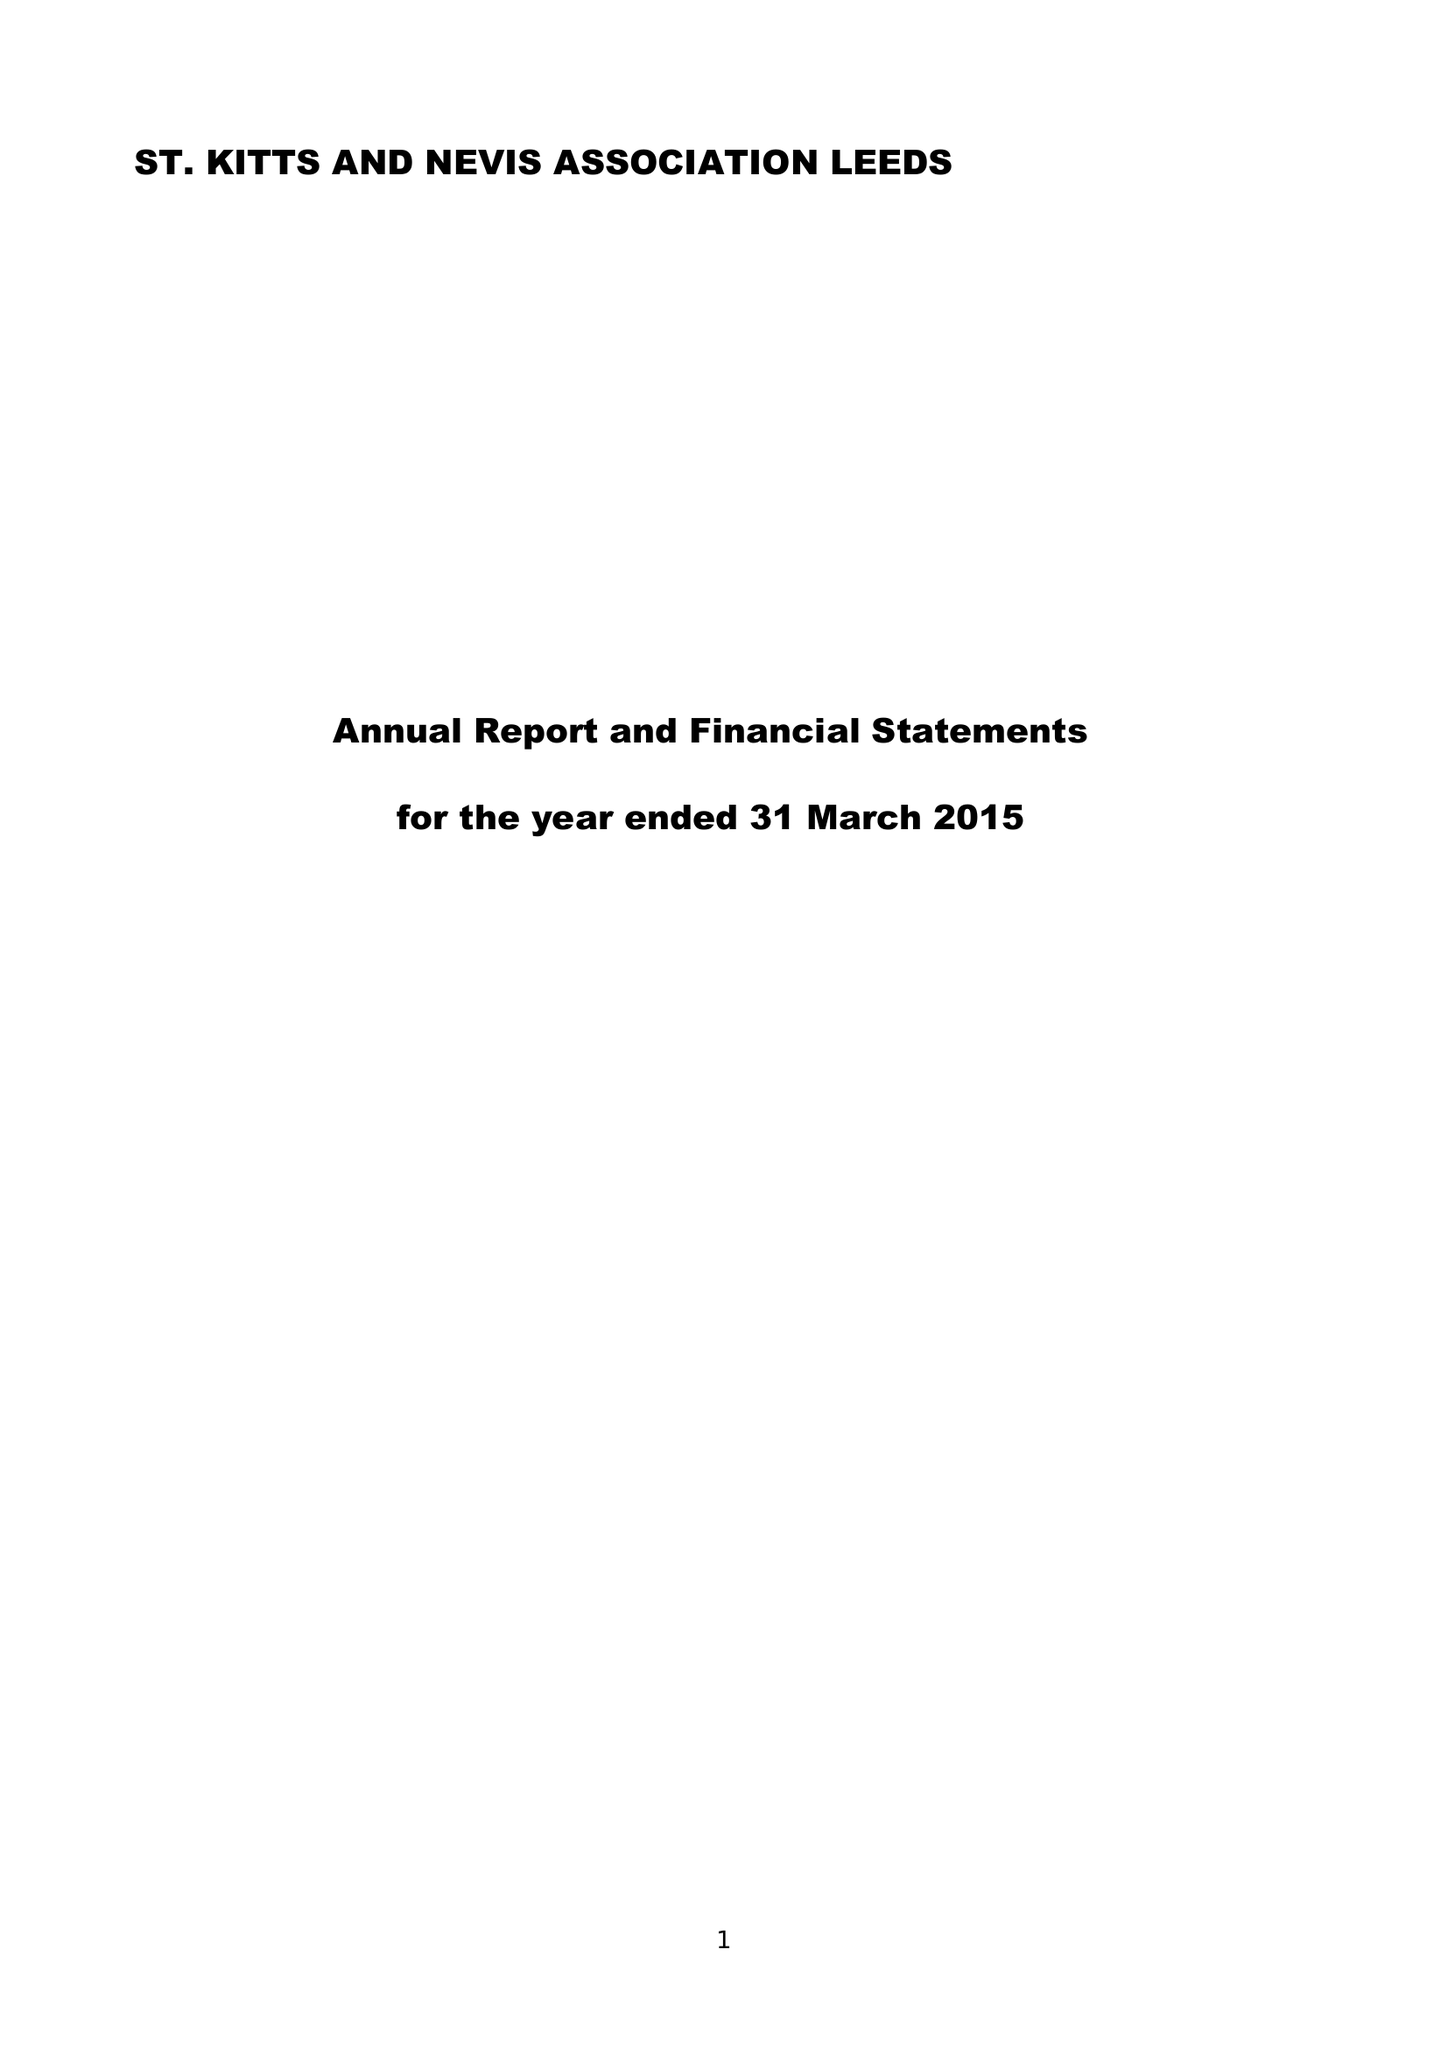What is the value for the address__post_town?
Answer the question using a single word or phrase. LEEDS 